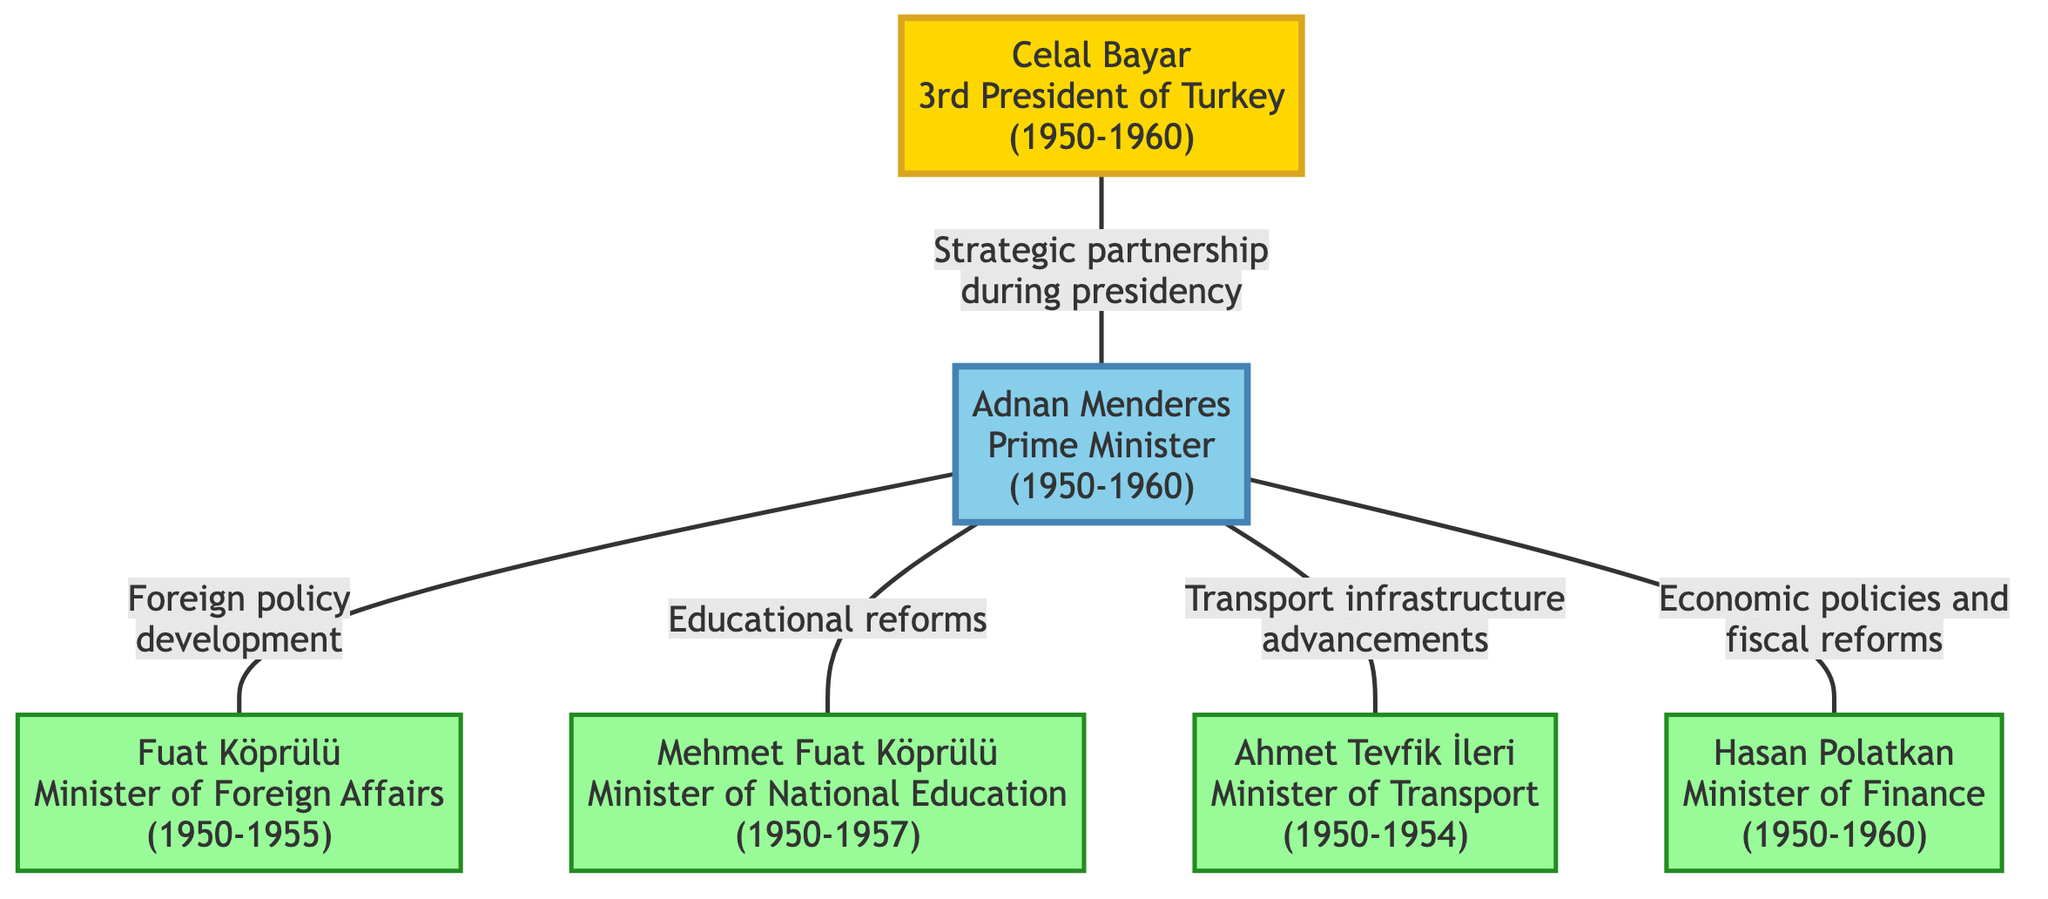What is the role of Celal Bayar in the diagram? The diagram identifies Celal Bayar as the "3rd President of Turkey" from 1950 to 1960, indicating his significant leadership role during this period.
Answer: 3rd President of Turkey How many people are identified in the diagram? The diagram features five distinct individuals: Celal Bayar, Adnan Menderes, Fuat Köprülü, Mehmet Fuat Köprülü, Ahmet Tevfik İleri, and Hasan Polatkan, totaling six individuals mentioned.
Answer: 6 Which individual is linked to Foreign Policy development? The diagram directly links Adnan Menderes with Fuat Köprülü under the label "Foreign policy development." This indicates that Fuat Köprülü was responsible for advancing foreign policy while Menderes was Prime Minister.
Answer: Fuat Köprülü Who served as the Minister of National Education? The diagram states that Mehmet Fuat Köprülü held the position of Minister of National Education from 1950 to 1957, clearly identifying his role in educational initiatives.
Answer: Mehmet Fuat Köprülü What connection is illustrated between Adnan Menderes and Hasan Polatkan? The diagram connects Adnan Menderes to Hasan Polatkan through "Economic policies and fiscal reforms," indicating their collaborative efforts in economic management during Menderes' premiership.
Answer: Economic policies and fiscal reforms What positions did Hasan Polatkan hold during the Democrat Party era? According to the diagram, Hasan Polatkan served as the Minister of Finance from 1950 to 1960, highlighting his significance in financial governance during that era.
Answer: Minister of Finance How is Adnan Menderes characterized in relation to Celal Bayar? The diagram illustrates a direct connection labeled "Strategic partnership during presidency" between Celal Bayar and Adnan Menderes, emphasizing their cooperative relationship throughout Menderes' time in office.
Answer: Strategic partnership during presidency What is the timeline of Adnan Menderes’ premiership? The diagram specifies that Adnan Menderes was Prime Minister from 1950 to 1960, providing a clear timeline for his leadership period.
Answer: 1950-1960 Which minister was involved with Transport infrastructure? The diagram indicates that Ahmet Tevfik İleri was responsible for "Transport infrastructure advancements" during his term as Minister of Transport from 1950 to 1954.
Answer: Ahmet Tevfik İleri 